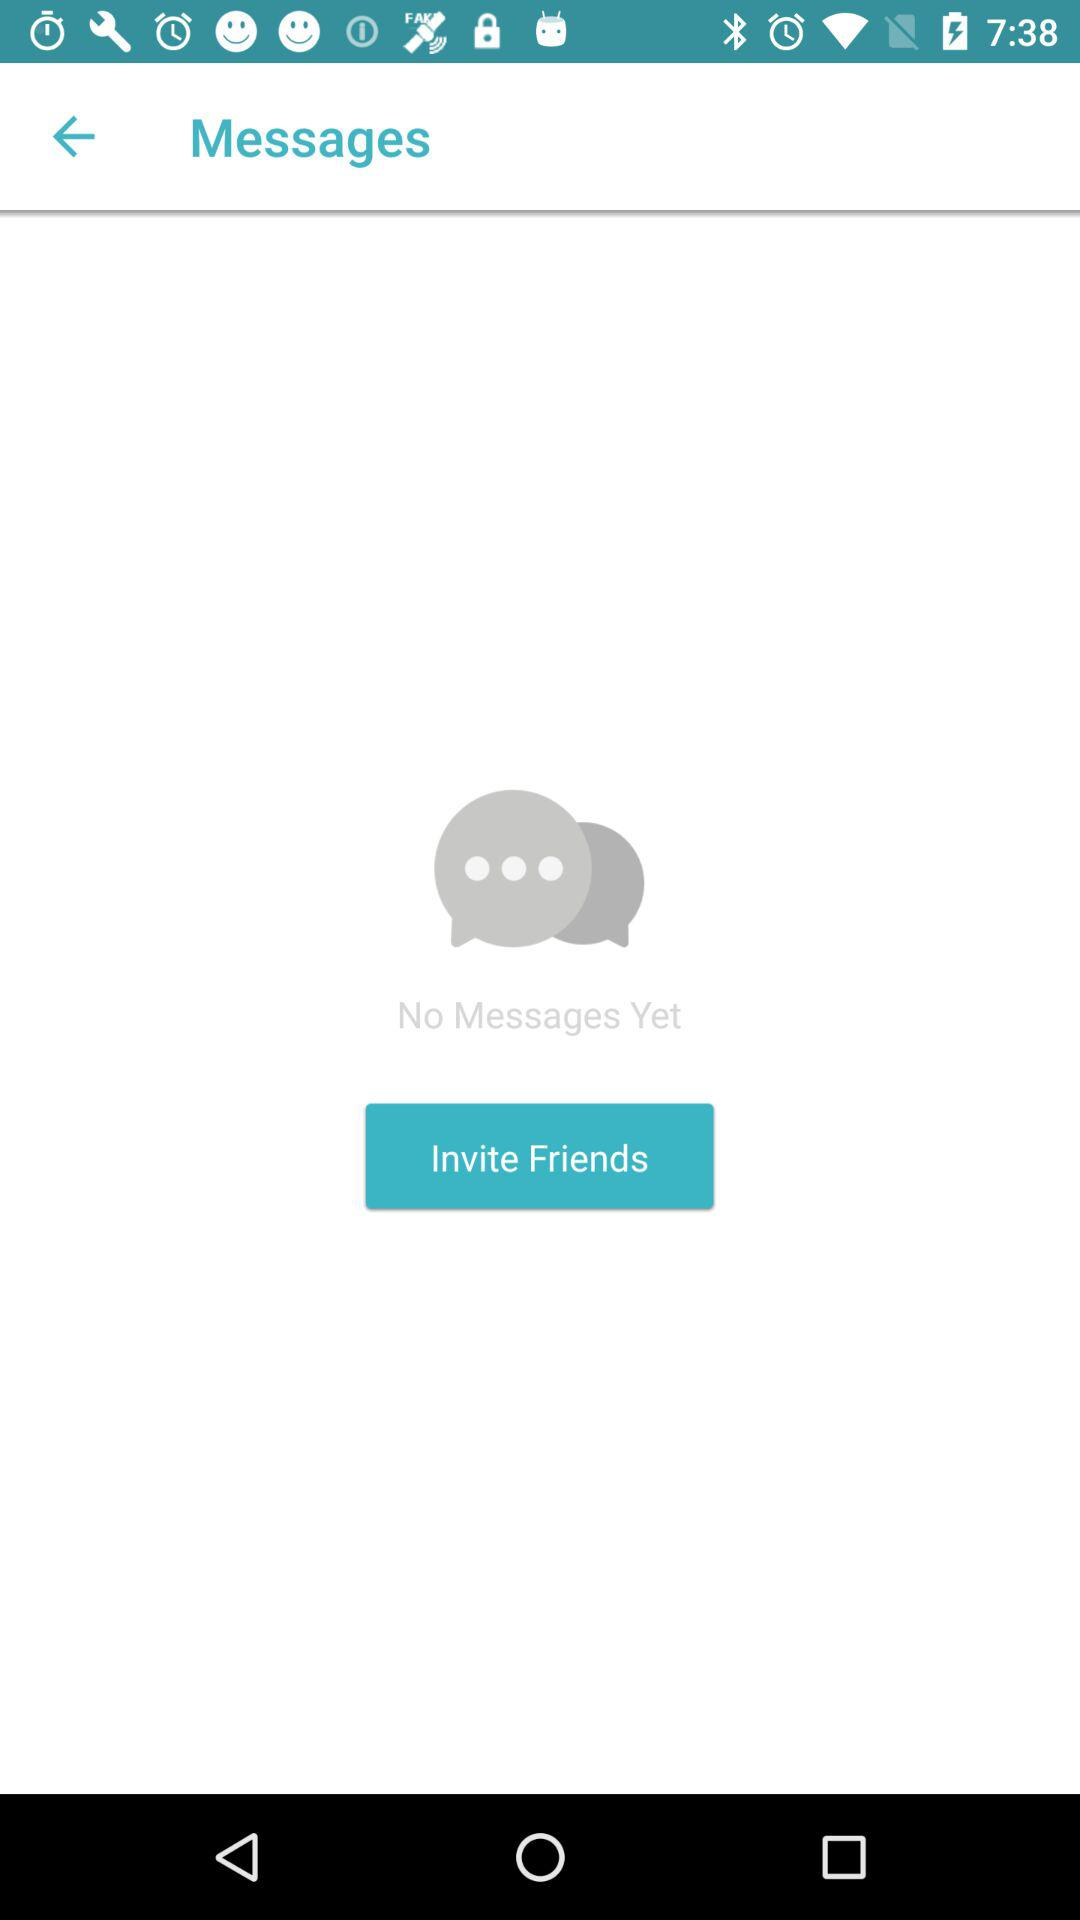Are there any messages? There are no messages. 